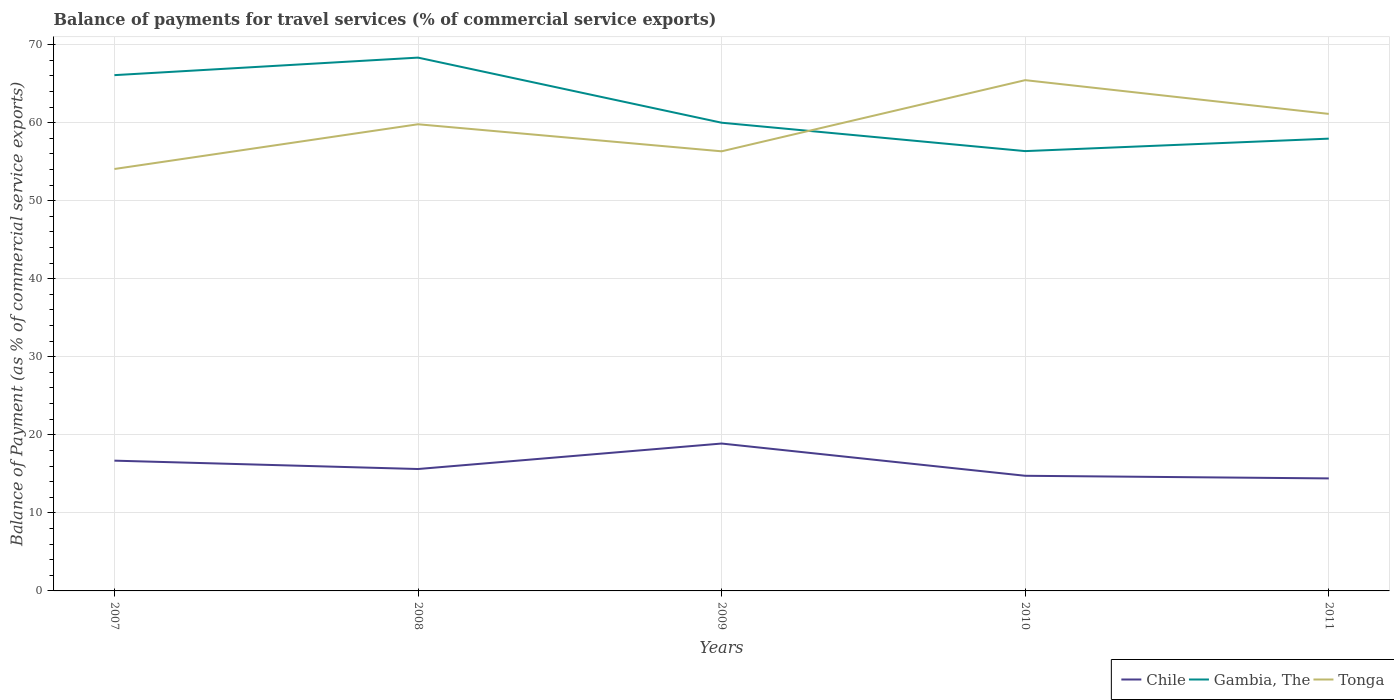How many different coloured lines are there?
Make the answer very short. 3. Across all years, what is the maximum balance of payments for travel services in Tonga?
Your answer should be compact. 54.06. What is the total balance of payments for travel services in Chile in the graph?
Ensure brevity in your answer.  2.27. What is the difference between the highest and the second highest balance of payments for travel services in Tonga?
Offer a very short reply. 11.38. What is the difference between the highest and the lowest balance of payments for travel services in Tonga?
Give a very brief answer. 3. How many lines are there?
Make the answer very short. 3. How many years are there in the graph?
Give a very brief answer. 5. Are the values on the major ticks of Y-axis written in scientific E-notation?
Offer a very short reply. No. How many legend labels are there?
Provide a succinct answer. 3. What is the title of the graph?
Your answer should be compact. Balance of payments for travel services (% of commercial service exports). What is the label or title of the X-axis?
Provide a succinct answer. Years. What is the label or title of the Y-axis?
Your answer should be very brief. Balance of Payment (as % of commercial service exports). What is the Balance of Payment (as % of commercial service exports) of Chile in 2007?
Offer a very short reply. 16.69. What is the Balance of Payment (as % of commercial service exports) of Gambia, The in 2007?
Make the answer very short. 66.09. What is the Balance of Payment (as % of commercial service exports) of Tonga in 2007?
Your response must be concise. 54.06. What is the Balance of Payment (as % of commercial service exports) of Chile in 2008?
Your answer should be compact. 15.62. What is the Balance of Payment (as % of commercial service exports) in Gambia, The in 2008?
Offer a terse response. 68.33. What is the Balance of Payment (as % of commercial service exports) of Tonga in 2008?
Offer a very short reply. 59.79. What is the Balance of Payment (as % of commercial service exports) in Chile in 2009?
Give a very brief answer. 18.88. What is the Balance of Payment (as % of commercial service exports) of Gambia, The in 2009?
Provide a short and direct response. 59.99. What is the Balance of Payment (as % of commercial service exports) in Tonga in 2009?
Give a very brief answer. 56.33. What is the Balance of Payment (as % of commercial service exports) in Chile in 2010?
Provide a succinct answer. 14.75. What is the Balance of Payment (as % of commercial service exports) of Gambia, The in 2010?
Offer a very short reply. 56.35. What is the Balance of Payment (as % of commercial service exports) in Tonga in 2010?
Provide a succinct answer. 65.44. What is the Balance of Payment (as % of commercial service exports) in Chile in 2011?
Provide a succinct answer. 14.42. What is the Balance of Payment (as % of commercial service exports) in Gambia, The in 2011?
Give a very brief answer. 57.95. What is the Balance of Payment (as % of commercial service exports) of Tonga in 2011?
Provide a succinct answer. 61.12. Across all years, what is the maximum Balance of Payment (as % of commercial service exports) in Chile?
Give a very brief answer. 18.88. Across all years, what is the maximum Balance of Payment (as % of commercial service exports) of Gambia, The?
Make the answer very short. 68.33. Across all years, what is the maximum Balance of Payment (as % of commercial service exports) of Tonga?
Your answer should be very brief. 65.44. Across all years, what is the minimum Balance of Payment (as % of commercial service exports) in Chile?
Your response must be concise. 14.42. Across all years, what is the minimum Balance of Payment (as % of commercial service exports) of Gambia, The?
Offer a terse response. 56.35. Across all years, what is the minimum Balance of Payment (as % of commercial service exports) of Tonga?
Give a very brief answer. 54.06. What is the total Balance of Payment (as % of commercial service exports) of Chile in the graph?
Offer a terse response. 80.36. What is the total Balance of Payment (as % of commercial service exports) in Gambia, The in the graph?
Offer a very short reply. 308.71. What is the total Balance of Payment (as % of commercial service exports) of Tonga in the graph?
Give a very brief answer. 296.74. What is the difference between the Balance of Payment (as % of commercial service exports) of Chile in 2007 and that in 2008?
Your answer should be compact. 1.07. What is the difference between the Balance of Payment (as % of commercial service exports) in Gambia, The in 2007 and that in 2008?
Provide a short and direct response. -2.24. What is the difference between the Balance of Payment (as % of commercial service exports) of Tonga in 2007 and that in 2008?
Make the answer very short. -5.73. What is the difference between the Balance of Payment (as % of commercial service exports) of Chile in 2007 and that in 2009?
Your answer should be compact. -2.19. What is the difference between the Balance of Payment (as % of commercial service exports) of Gambia, The in 2007 and that in 2009?
Offer a terse response. 6.1. What is the difference between the Balance of Payment (as % of commercial service exports) of Tonga in 2007 and that in 2009?
Your response must be concise. -2.27. What is the difference between the Balance of Payment (as % of commercial service exports) of Chile in 2007 and that in 2010?
Offer a very short reply. 1.94. What is the difference between the Balance of Payment (as % of commercial service exports) of Gambia, The in 2007 and that in 2010?
Offer a very short reply. 9.73. What is the difference between the Balance of Payment (as % of commercial service exports) of Tonga in 2007 and that in 2010?
Keep it short and to the point. -11.38. What is the difference between the Balance of Payment (as % of commercial service exports) in Chile in 2007 and that in 2011?
Your answer should be compact. 2.27. What is the difference between the Balance of Payment (as % of commercial service exports) in Gambia, The in 2007 and that in 2011?
Keep it short and to the point. 8.14. What is the difference between the Balance of Payment (as % of commercial service exports) in Tonga in 2007 and that in 2011?
Offer a very short reply. -7.06. What is the difference between the Balance of Payment (as % of commercial service exports) of Chile in 2008 and that in 2009?
Keep it short and to the point. -3.26. What is the difference between the Balance of Payment (as % of commercial service exports) of Gambia, The in 2008 and that in 2009?
Offer a terse response. 8.34. What is the difference between the Balance of Payment (as % of commercial service exports) of Tonga in 2008 and that in 2009?
Offer a very short reply. 3.47. What is the difference between the Balance of Payment (as % of commercial service exports) of Chile in 2008 and that in 2010?
Ensure brevity in your answer.  0.87. What is the difference between the Balance of Payment (as % of commercial service exports) in Gambia, The in 2008 and that in 2010?
Your answer should be very brief. 11.98. What is the difference between the Balance of Payment (as % of commercial service exports) in Tonga in 2008 and that in 2010?
Provide a short and direct response. -5.65. What is the difference between the Balance of Payment (as % of commercial service exports) of Chile in 2008 and that in 2011?
Provide a succinct answer. 1.2. What is the difference between the Balance of Payment (as % of commercial service exports) in Gambia, The in 2008 and that in 2011?
Your answer should be very brief. 10.38. What is the difference between the Balance of Payment (as % of commercial service exports) in Tonga in 2008 and that in 2011?
Make the answer very short. -1.33. What is the difference between the Balance of Payment (as % of commercial service exports) of Chile in 2009 and that in 2010?
Ensure brevity in your answer.  4.13. What is the difference between the Balance of Payment (as % of commercial service exports) in Gambia, The in 2009 and that in 2010?
Offer a terse response. 3.64. What is the difference between the Balance of Payment (as % of commercial service exports) of Tonga in 2009 and that in 2010?
Provide a succinct answer. -9.12. What is the difference between the Balance of Payment (as % of commercial service exports) in Chile in 2009 and that in 2011?
Your answer should be compact. 4.47. What is the difference between the Balance of Payment (as % of commercial service exports) of Gambia, The in 2009 and that in 2011?
Your answer should be compact. 2.04. What is the difference between the Balance of Payment (as % of commercial service exports) in Tonga in 2009 and that in 2011?
Provide a short and direct response. -4.79. What is the difference between the Balance of Payment (as % of commercial service exports) of Chile in 2010 and that in 2011?
Your answer should be very brief. 0.34. What is the difference between the Balance of Payment (as % of commercial service exports) in Gambia, The in 2010 and that in 2011?
Keep it short and to the point. -1.6. What is the difference between the Balance of Payment (as % of commercial service exports) in Tonga in 2010 and that in 2011?
Offer a very short reply. 4.33. What is the difference between the Balance of Payment (as % of commercial service exports) in Chile in 2007 and the Balance of Payment (as % of commercial service exports) in Gambia, The in 2008?
Make the answer very short. -51.64. What is the difference between the Balance of Payment (as % of commercial service exports) of Chile in 2007 and the Balance of Payment (as % of commercial service exports) of Tonga in 2008?
Keep it short and to the point. -43.1. What is the difference between the Balance of Payment (as % of commercial service exports) in Gambia, The in 2007 and the Balance of Payment (as % of commercial service exports) in Tonga in 2008?
Your answer should be very brief. 6.29. What is the difference between the Balance of Payment (as % of commercial service exports) of Chile in 2007 and the Balance of Payment (as % of commercial service exports) of Gambia, The in 2009?
Keep it short and to the point. -43.3. What is the difference between the Balance of Payment (as % of commercial service exports) of Chile in 2007 and the Balance of Payment (as % of commercial service exports) of Tonga in 2009?
Your answer should be very brief. -39.64. What is the difference between the Balance of Payment (as % of commercial service exports) in Gambia, The in 2007 and the Balance of Payment (as % of commercial service exports) in Tonga in 2009?
Offer a terse response. 9.76. What is the difference between the Balance of Payment (as % of commercial service exports) of Chile in 2007 and the Balance of Payment (as % of commercial service exports) of Gambia, The in 2010?
Keep it short and to the point. -39.66. What is the difference between the Balance of Payment (as % of commercial service exports) in Chile in 2007 and the Balance of Payment (as % of commercial service exports) in Tonga in 2010?
Keep it short and to the point. -48.75. What is the difference between the Balance of Payment (as % of commercial service exports) in Gambia, The in 2007 and the Balance of Payment (as % of commercial service exports) in Tonga in 2010?
Make the answer very short. 0.64. What is the difference between the Balance of Payment (as % of commercial service exports) in Chile in 2007 and the Balance of Payment (as % of commercial service exports) in Gambia, The in 2011?
Make the answer very short. -41.26. What is the difference between the Balance of Payment (as % of commercial service exports) of Chile in 2007 and the Balance of Payment (as % of commercial service exports) of Tonga in 2011?
Ensure brevity in your answer.  -44.43. What is the difference between the Balance of Payment (as % of commercial service exports) in Gambia, The in 2007 and the Balance of Payment (as % of commercial service exports) in Tonga in 2011?
Provide a succinct answer. 4.97. What is the difference between the Balance of Payment (as % of commercial service exports) of Chile in 2008 and the Balance of Payment (as % of commercial service exports) of Gambia, The in 2009?
Keep it short and to the point. -44.37. What is the difference between the Balance of Payment (as % of commercial service exports) of Chile in 2008 and the Balance of Payment (as % of commercial service exports) of Tonga in 2009?
Keep it short and to the point. -40.71. What is the difference between the Balance of Payment (as % of commercial service exports) of Gambia, The in 2008 and the Balance of Payment (as % of commercial service exports) of Tonga in 2009?
Provide a short and direct response. 12.01. What is the difference between the Balance of Payment (as % of commercial service exports) of Chile in 2008 and the Balance of Payment (as % of commercial service exports) of Gambia, The in 2010?
Provide a succinct answer. -40.73. What is the difference between the Balance of Payment (as % of commercial service exports) of Chile in 2008 and the Balance of Payment (as % of commercial service exports) of Tonga in 2010?
Keep it short and to the point. -49.83. What is the difference between the Balance of Payment (as % of commercial service exports) of Gambia, The in 2008 and the Balance of Payment (as % of commercial service exports) of Tonga in 2010?
Ensure brevity in your answer.  2.89. What is the difference between the Balance of Payment (as % of commercial service exports) in Chile in 2008 and the Balance of Payment (as % of commercial service exports) in Gambia, The in 2011?
Your answer should be very brief. -42.33. What is the difference between the Balance of Payment (as % of commercial service exports) in Chile in 2008 and the Balance of Payment (as % of commercial service exports) in Tonga in 2011?
Keep it short and to the point. -45.5. What is the difference between the Balance of Payment (as % of commercial service exports) in Gambia, The in 2008 and the Balance of Payment (as % of commercial service exports) in Tonga in 2011?
Offer a terse response. 7.21. What is the difference between the Balance of Payment (as % of commercial service exports) in Chile in 2009 and the Balance of Payment (as % of commercial service exports) in Gambia, The in 2010?
Make the answer very short. -37.47. What is the difference between the Balance of Payment (as % of commercial service exports) of Chile in 2009 and the Balance of Payment (as % of commercial service exports) of Tonga in 2010?
Your answer should be very brief. -46.56. What is the difference between the Balance of Payment (as % of commercial service exports) of Gambia, The in 2009 and the Balance of Payment (as % of commercial service exports) of Tonga in 2010?
Your answer should be compact. -5.45. What is the difference between the Balance of Payment (as % of commercial service exports) in Chile in 2009 and the Balance of Payment (as % of commercial service exports) in Gambia, The in 2011?
Your answer should be very brief. -39.07. What is the difference between the Balance of Payment (as % of commercial service exports) in Chile in 2009 and the Balance of Payment (as % of commercial service exports) in Tonga in 2011?
Offer a terse response. -42.24. What is the difference between the Balance of Payment (as % of commercial service exports) in Gambia, The in 2009 and the Balance of Payment (as % of commercial service exports) in Tonga in 2011?
Give a very brief answer. -1.13. What is the difference between the Balance of Payment (as % of commercial service exports) of Chile in 2010 and the Balance of Payment (as % of commercial service exports) of Gambia, The in 2011?
Offer a terse response. -43.2. What is the difference between the Balance of Payment (as % of commercial service exports) of Chile in 2010 and the Balance of Payment (as % of commercial service exports) of Tonga in 2011?
Offer a terse response. -46.37. What is the difference between the Balance of Payment (as % of commercial service exports) in Gambia, The in 2010 and the Balance of Payment (as % of commercial service exports) in Tonga in 2011?
Offer a very short reply. -4.77. What is the average Balance of Payment (as % of commercial service exports) of Chile per year?
Keep it short and to the point. 16.07. What is the average Balance of Payment (as % of commercial service exports) in Gambia, The per year?
Ensure brevity in your answer.  61.74. What is the average Balance of Payment (as % of commercial service exports) of Tonga per year?
Your answer should be compact. 59.35. In the year 2007, what is the difference between the Balance of Payment (as % of commercial service exports) in Chile and Balance of Payment (as % of commercial service exports) in Gambia, The?
Provide a short and direct response. -49.4. In the year 2007, what is the difference between the Balance of Payment (as % of commercial service exports) in Chile and Balance of Payment (as % of commercial service exports) in Tonga?
Your answer should be compact. -37.37. In the year 2007, what is the difference between the Balance of Payment (as % of commercial service exports) of Gambia, The and Balance of Payment (as % of commercial service exports) of Tonga?
Keep it short and to the point. 12.03. In the year 2008, what is the difference between the Balance of Payment (as % of commercial service exports) in Chile and Balance of Payment (as % of commercial service exports) in Gambia, The?
Your answer should be very brief. -52.71. In the year 2008, what is the difference between the Balance of Payment (as % of commercial service exports) in Chile and Balance of Payment (as % of commercial service exports) in Tonga?
Your answer should be compact. -44.17. In the year 2008, what is the difference between the Balance of Payment (as % of commercial service exports) of Gambia, The and Balance of Payment (as % of commercial service exports) of Tonga?
Offer a terse response. 8.54. In the year 2009, what is the difference between the Balance of Payment (as % of commercial service exports) in Chile and Balance of Payment (as % of commercial service exports) in Gambia, The?
Offer a very short reply. -41.11. In the year 2009, what is the difference between the Balance of Payment (as % of commercial service exports) of Chile and Balance of Payment (as % of commercial service exports) of Tonga?
Offer a terse response. -37.44. In the year 2009, what is the difference between the Balance of Payment (as % of commercial service exports) in Gambia, The and Balance of Payment (as % of commercial service exports) in Tonga?
Your answer should be compact. 3.66. In the year 2010, what is the difference between the Balance of Payment (as % of commercial service exports) in Chile and Balance of Payment (as % of commercial service exports) in Gambia, The?
Give a very brief answer. -41.6. In the year 2010, what is the difference between the Balance of Payment (as % of commercial service exports) in Chile and Balance of Payment (as % of commercial service exports) in Tonga?
Make the answer very short. -50.69. In the year 2010, what is the difference between the Balance of Payment (as % of commercial service exports) in Gambia, The and Balance of Payment (as % of commercial service exports) in Tonga?
Your answer should be very brief. -9.09. In the year 2011, what is the difference between the Balance of Payment (as % of commercial service exports) in Chile and Balance of Payment (as % of commercial service exports) in Gambia, The?
Give a very brief answer. -43.53. In the year 2011, what is the difference between the Balance of Payment (as % of commercial service exports) in Chile and Balance of Payment (as % of commercial service exports) in Tonga?
Make the answer very short. -46.7. In the year 2011, what is the difference between the Balance of Payment (as % of commercial service exports) in Gambia, The and Balance of Payment (as % of commercial service exports) in Tonga?
Offer a terse response. -3.17. What is the ratio of the Balance of Payment (as % of commercial service exports) in Chile in 2007 to that in 2008?
Make the answer very short. 1.07. What is the ratio of the Balance of Payment (as % of commercial service exports) in Gambia, The in 2007 to that in 2008?
Offer a very short reply. 0.97. What is the ratio of the Balance of Payment (as % of commercial service exports) in Tonga in 2007 to that in 2008?
Your response must be concise. 0.9. What is the ratio of the Balance of Payment (as % of commercial service exports) of Chile in 2007 to that in 2009?
Give a very brief answer. 0.88. What is the ratio of the Balance of Payment (as % of commercial service exports) in Gambia, The in 2007 to that in 2009?
Offer a terse response. 1.1. What is the ratio of the Balance of Payment (as % of commercial service exports) in Tonga in 2007 to that in 2009?
Make the answer very short. 0.96. What is the ratio of the Balance of Payment (as % of commercial service exports) in Chile in 2007 to that in 2010?
Offer a very short reply. 1.13. What is the ratio of the Balance of Payment (as % of commercial service exports) in Gambia, The in 2007 to that in 2010?
Offer a very short reply. 1.17. What is the ratio of the Balance of Payment (as % of commercial service exports) of Tonga in 2007 to that in 2010?
Your answer should be very brief. 0.83. What is the ratio of the Balance of Payment (as % of commercial service exports) of Chile in 2007 to that in 2011?
Keep it short and to the point. 1.16. What is the ratio of the Balance of Payment (as % of commercial service exports) of Gambia, The in 2007 to that in 2011?
Give a very brief answer. 1.14. What is the ratio of the Balance of Payment (as % of commercial service exports) in Tonga in 2007 to that in 2011?
Offer a terse response. 0.88. What is the ratio of the Balance of Payment (as % of commercial service exports) of Chile in 2008 to that in 2009?
Your response must be concise. 0.83. What is the ratio of the Balance of Payment (as % of commercial service exports) in Gambia, The in 2008 to that in 2009?
Make the answer very short. 1.14. What is the ratio of the Balance of Payment (as % of commercial service exports) of Tonga in 2008 to that in 2009?
Offer a very short reply. 1.06. What is the ratio of the Balance of Payment (as % of commercial service exports) in Chile in 2008 to that in 2010?
Your answer should be compact. 1.06. What is the ratio of the Balance of Payment (as % of commercial service exports) of Gambia, The in 2008 to that in 2010?
Make the answer very short. 1.21. What is the ratio of the Balance of Payment (as % of commercial service exports) of Tonga in 2008 to that in 2010?
Keep it short and to the point. 0.91. What is the ratio of the Balance of Payment (as % of commercial service exports) of Chile in 2008 to that in 2011?
Make the answer very short. 1.08. What is the ratio of the Balance of Payment (as % of commercial service exports) of Gambia, The in 2008 to that in 2011?
Ensure brevity in your answer.  1.18. What is the ratio of the Balance of Payment (as % of commercial service exports) of Tonga in 2008 to that in 2011?
Give a very brief answer. 0.98. What is the ratio of the Balance of Payment (as % of commercial service exports) in Chile in 2009 to that in 2010?
Your answer should be very brief. 1.28. What is the ratio of the Balance of Payment (as % of commercial service exports) of Gambia, The in 2009 to that in 2010?
Keep it short and to the point. 1.06. What is the ratio of the Balance of Payment (as % of commercial service exports) of Tonga in 2009 to that in 2010?
Keep it short and to the point. 0.86. What is the ratio of the Balance of Payment (as % of commercial service exports) of Chile in 2009 to that in 2011?
Ensure brevity in your answer.  1.31. What is the ratio of the Balance of Payment (as % of commercial service exports) of Gambia, The in 2009 to that in 2011?
Your answer should be compact. 1.04. What is the ratio of the Balance of Payment (as % of commercial service exports) of Tonga in 2009 to that in 2011?
Offer a very short reply. 0.92. What is the ratio of the Balance of Payment (as % of commercial service exports) in Chile in 2010 to that in 2011?
Your answer should be very brief. 1.02. What is the ratio of the Balance of Payment (as % of commercial service exports) in Gambia, The in 2010 to that in 2011?
Offer a very short reply. 0.97. What is the ratio of the Balance of Payment (as % of commercial service exports) in Tonga in 2010 to that in 2011?
Your response must be concise. 1.07. What is the difference between the highest and the second highest Balance of Payment (as % of commercial service exports) in Chile?
Make the answer very short. 2.19. What is the difference between the highest and the second highest Balance of Payment (as % of commercial service exports) of Gambia, The?
Ensure brevity in your answer.  2.24. What is the difference between the highest and the second highest Balance of Payment (as % of commercial service exports) of Tonga?
Keep it short and to the point. 4.33. What is the difference between the highest and the lowest Balance of Payment (as % of commercial service exports) in Chile?
Offer a terse response. 4.47. What is the difference between the highest and the lowest Balance of Payment (as % of commercial service exports) in Gambia, The?
Your answer should be compact. 11.98. What is the difference between the highest and the lowest Balance of Payment (as % of commercial service exports) in Tonga?
Keep it short and to the point. 11.38. 